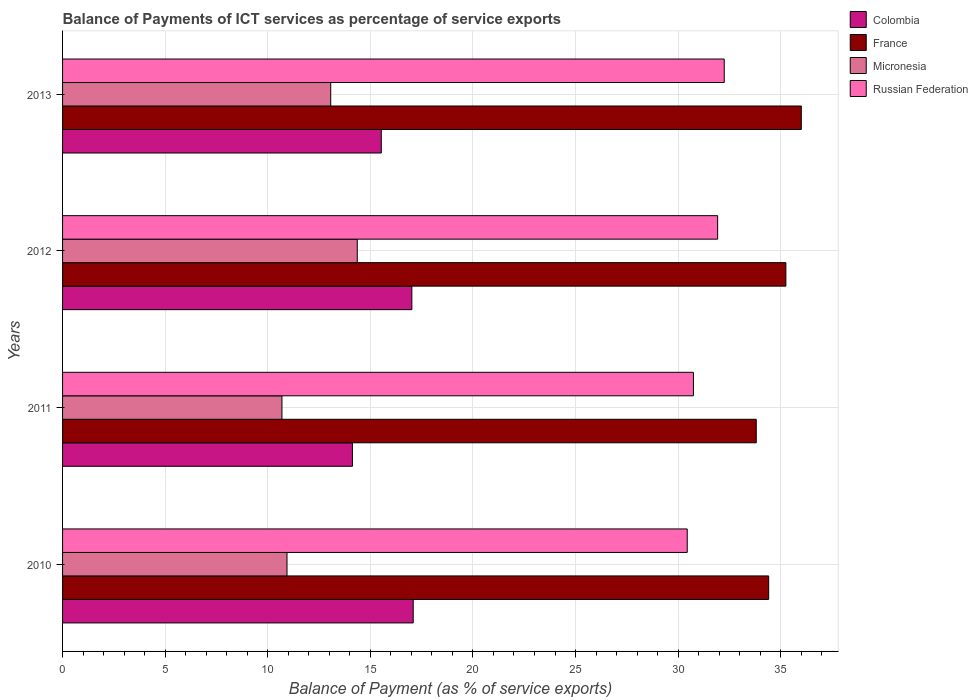How many different coloured bars are there?
Your answer should be very brief. 4. How many groups of bars are there?
Offer a very short reply. 4. Are the number of bars on each tick of the Y-axis equal?
Offer a very short reply. Yes. How many bars are there on the 3rd tick from the top?
Your answer should be compact. 4. What is the label of the 3rd group of bars from the top?
Keep it short and to the point. 2011. In how many cases, is the number of bars for a given year not equal to the number of legend labels?
Give a very brief answer. 0. What is the balance of payments of ICT services in Russian Federation in 2011?
Your answer should be very brief. 30.74. Across all years, what is the maximum balance of payments of ICT services in Colombia?
Ensure brevity in your answer.  17.09. Across all years, what is the minimum balance of payments of ICT services in Russian Federation?
Provide a succinct answer. 30.44. In which year was the balance of payments of ICT services in France minimum?
Your answer should be compact. 2011. What is the total balance of payments of ICT services in Russian Federation in the graph?
Offer a very short reply. 125.36. What is the difference between the balance of payments of ICT services in France in 2010 and that in 2011?
Make the answer very short. 0.61. What is the difference between the balance of payments of ICT services in France in 2011 and the balance of payments of ICT services in Colombia in 2012?
Your response must be concise. 16.78. What is the average balance of payments of ICT services in Colombia per year?
Make the answer very short. 15.94. In the year 2013, what is the difference between the balance of payments of ICT services in Micronesia and balance of payments of ICT services in France?
Your answer should be very brief. -22.93. In how many years, is the balance of payments of ICT services in Micronesia greater than 4 %?
Your response must be concise. 4. What is the ratio of the balance of payments of ICT services in Micronesia in 2010 to that in 2012?
Ensure brevity in your answer.  0.76. Is the difference between the balance of payments of ICT services in Micronesia in 2010 and 2013 greater than the difference between the balance of payments of ICT services in France in 2010 and 2013?
Give a very brief answer. No. What is the difference between the highest and the second highest balance of payments of ICT services in Russian Federation?
Keep it short and to the point. 0.32. What is the difference between the highest and the lowest balance of payments of ICT services in Colombia?
Provide a short and direct response. 2.96. In how many years, is the balance of payments of ICT services in Russian Federation greater than the average balance of payments of ICT services in Russian Federation taken over all years?
Keep it short and to the point. 2. Is the sum of the balance of payments of ICT services in Micronesia in 2010 and 2012 greater than the maximum balance of payments of ICT services in France across all years?
Provide a succinct answer. No. Is it the case that in every year, the sum of the balance of payments of ICT services in Colombia and balance of payments of ICT services in Micronesia is greater than the sum of balance of payments of ICT services in France and balance of payments of ICT services in Russian Federation?
Give a very brief answer. No. What does the 4th bar from the bottom in 2011 represents?
Give a very brief answer. Russian Federation. Are all the bars in the graph horizontal?
Your response must be concise. Yes. What is the difference between two consecutive major ticks on the X-axis?
Give a very brief answer. 5. Are the values on the major ticks of X-axis written in scientific E-notation?
Your answer should be very brief. No. Does the graph contain grids?
Your response must be concise. Yes. Where does the legend appear in the graph?
Offer a terse response. Top right. How many legend labels are there?
Offer a very short reply. 4. How are the legend labels stacked?
Offer a very short reply. Vertical. What is the title of the graph?
Offer a very short reply. Balance of Payments of ICT services as percentage of service exports. What is the label or title of the X-axis?
Keep it short and to the point. Balance of Payment (as % of service exports). What is the Balance of Payment (as % of service exports) in Colombia in 2010?
Offer a terse response. 17.09. What is the Balance of Payment (as % of service exports) of France in 2010?
Offer a terse response. 34.41. What is the Balance of Payment (as % of service exports) of Micronesia in 2010?
Ensure brevity in your answer.  10.94. What is the Balance of Payment (as % of service exports) of Russian Federation in 2010?
Keep it short and to the point. 30.44. What is the Balance of Payment (as % of service exports) in Colombia in 2011?
Provide a succinct answer. 14.13. What is the Balance of Payment (as % of service exports) of France in 2011?
Your answer should be compact. 33.81. What is the Balance of Payment (as % of service exports) of Micronesia in 2011?
Your answer should be very brief. 10.69. What is the Balance of Payment (as % of service exports) of Russian Federation in 2011?
Ensure brevity in your answer.  30.74. What is the Balance of Payment (as % of service exports) of Colombia in 2012?
Give a very brief answer. 17.02. What is the Balance of Payment (as % of service exports) of France in 2012?
Your response must be concise. 35.25. What is the Balance of Payment (as % of service exports) in Micronesia in 2012?
Your answer should be very brief. 14.36. What is the Balance of Payment (as % of service exports) in Russian Federation in 2012?
Provide a succinct answer. 31.92. What is the Balance of Payment (as % of service exports) of Colombia in 2013?
Offer a terse response. 15.53. What is the Balance of Payment (as % of service exports) in France in 2013?
Provide a succinct answer. 36. What is the Balance of Payment (as % of service exports) of Micronesia in 2013?
Provide a succinct answer. 13.07. What is the Balance of Payment (as % of service exports) of Russian Federation in 2013?
Keep it short and to the point. 32.25. Across all years, what is the maximum Balance of Payment (as % of service exports) in Colombia?
Keep it short and to the point. 17.09. Across all years, what is the maximum Balance of Payment (as % of service exports) in France?
Offer a terse response. 36. Across all years, what is the maximum Balance of Payment (as % of service exports) of Micronesia?
Make the answer very short. 14.36. Across all years, what is the maximum Balance of Payment (as % of service exports) of Russian Federation?
Offer a terse response. 32.25. Across all years, what is the minimum Balance of Payment (as % of service exports) of Colombia?
Keep it short and to the point. 14.13. Across all years, what is the minimum Balance of Payment (as % of service exports) in France?
Your answer should be compact. 33.81. Across all years, what is the minimum Balance of Payment (as % of service exports) in Micronesia?
Make the answer very short. 10.69. Across all years, what is the minimum Balance of Payment (as % of service exports) of Russian Federation?
Provide a succinct answer. 30.44. What is the total Balance of Payment (as % of service exports) in Colombia in the graph?
Offer a terse response. 63.77. What is the total Balance of Payment (as % of service exports) in France in the graph?
Ensure brevity in your answer.  139.47. What is the total Balance of Payment (as % of service exports) of Micronesia in the graph?
Offer a terse response. 49.06. What is the total Balance of Payment (as % of service exports) of Russian Federation in the graph?
Ensure brevity in your answer.  125.36. What is the difference between the Balance of Payment (as % of service exports) of Colombia in 2010 and that in 2011?
Your answer should be very brief. 2.96. What is the difference between the Balance of Payment (as % of service exports) in France in 2010 and that in 2011?
Offer a very short reply. 0.61. What is the difference between the Balance of Payment (as % of service exports) of Micronesia in 2010 and that in 2011?
Give a very brief answer. 0.25. What is the difference between the Balance of Payment (as % of service exports) of Russian Federation in 2010 and that in 2011?
Provide a succinct answer. -0.3. What is the difference between the Balance of Payment (as % of service exports) of Colombia in 2010 and that in 2012?
Give a very brief answer. 0.07. What is the difference between the Balance of Payment (as % of service exports) of France in 2010 and that in 2012?
Ensure brevity in your answer.  -0.84. What is the difference between the Balance of Payment (as % of service exports) in Micronesia in 2010 and that in 2012?
Keep it short and to the point. -3.42. What is the difference between the Balance of Payment (as % of service exports) in Russian Federation in 2010 and that in 2012?
Your answer should be compact. -1.48. What is the difference between the Balance of Payment (as % of service exports) of Colombia in 2010 and that in 2013?
Your answer should be compact. 1.56. What is the difference between the Balance of Payment (as % of service exports) of France in 2010 and that in 2013?
Your answer should be very brief. -1.59. What is the difference between the Balance of Payment (as % of service exports) in Micronesia in 2010 and that in 2013?
Your response must be concise. -2.13. What is the difference between the Balance of Payment (as % of service exports) of Russian Federation in 2010 and that in 2013?
Offer a terse response. -1.8. What is the difference between the Balance of Payment (as % of service exports) of Colombia in 2011 and that in 2012?
Offer a very short reply. -2.9. What is the difference between the Balance of Payment (as % of service exports) in France in 2011 and that in 2012?
Offer a terse response. -1.44. What is the difference between the Balance of Payment (as % of service exports) in Micronesia in 2011 and that in 2012?
Give a very brief answer. -3.67. What is the difference between the Balance of Payment (as % of service exports) of Russian Federation in 2011 and that in 2012?
Make the answer very short. -1.18. What is the difference between the Balance of Payment (as % of service exports) in Colombia in 2011 and that in 2013?
Provide a short and direct response. -1.41. What is the difference between the Balance of Payment (as % of service exports) in France in 2011 and that in 2013?
Your response must be concise. -2.19. What is the difference between the Balance of Payment (as % of service exports) in Micronesia in 2011 and that in 2013?
Give a very brief answer. -2.38. What is the difference between the Balance of Payment (as % of service exports) in Russian Federation in 2011 and that in 2013?
Give a very brief answer. -1.5. What is the difference between the Balance of Payment (as % of service exports) in Colombia in 2012 and that in 2013?
Your answer should be very brief. 1.49. What is the difference between the Balance of Payment (as % of service exports) of France in 2012 and that in 2013?
Ensure brevity in your answer.  -0.75. What is the difference between the Balance of Payment (as % of service exports) of Micronesia in 2012 and that in 2013?
Provide a short and direct response. 1.29. What is the difference between the Balance of Payment (as % of service exports) in Russian Federation in 2012 and that in 2013?
Provide a succinct answer. -0.32. What is the difference between the Balance of Payment (as % of service exports) of Colombia in 2010 and the Balance of Payment (as % of service exports) of France in 2011?
Your answer should be compact. -16.72. What is the difference between the Balance of Payment (as % of service exports) in Colombia in 2010 and the Balance of Payment (as % of service exports) in Micronesia in 2011?
Ensure brevity in your answer.  6.4. What is the difference between the Balance of Payment (as % of service exports) of Colombia in 2010 and the Balance of Payment (as % of service exports) of Russian Federation in 2011?
Give a very brief answer. -13.66. What is the difference between the Balance of Payment (as % of service exports) in France in 2010 and the Balance of Payment (as % of service exports) in Micronesia in 2011?
Keep it short and to the point. 23.72. What is the difference between the Balance of Payment (as % of service exports) in France in 2010 and the Balance of Payment (as % of service exports) in Russian Federation in 2011?
Provide a succinct answer. 3.67. What is the difference between the Balance of Payment (as % of service exports) of Micronesia in 2010 and the Balance of Payment (as % of service exports) of Russian Federation in 2011?
Your answer should be very brief. -19.81. What is the difference between the Balance of Payment (as % of service exports) in Colombia in 2010 and the Balance of Payment (as % of service exports) in France in 2012?
Provide a short and direct response. -18.16. What is the difference between the Balance of Payment (as % of service exports) of Colombia in 2010 and the Balance of Payment (as % of service exports) of Micronesia in 2012?
Make the answer very short. 2.73. What is the difference between the Balance of Payment (as % of service exports) of Colombia in 2010 and the Balance of Payment (as % of service exports) of Russian Federation in 2012?
Keep it short and to the point. -14.84. What is the difference between the Balance of Payment (as % of service exports) of France in 2010 and the Balance of Payment (as % of service exports) of Micronesia in 2012?
Make the answer very short. 20.05. What is the difference between the Balance of Payment (as % of service exports) of France in 2010 and the Balance of Payment (as % of service exports) of Russian Federation in 2012?
Provide a succinct answer. 2.49. What is the difference between the Balance of Payment (as % of service exports) of Micronesia in 2010 and the Balance of Payment (as % of service exports) of Russian Federation in 2012?
Ensure brevity in your answer.  -20.99. What is the difference between the Balance of Payment (as % of service exports) of Colombia in 2010 and the Balance of Payment (as % of service exports) of France in 2013?
Keep it short and to the point. -18.91. What is the difference between the Balance of Payment (as % of service exports) in Colombia in 2010 and the Balance of Payment (as % of service exports) in Micronesia in 2013?
Provide a succinct answer. 4.02. What is the difference between the Balance of Payment (as % of service exports) in Colombia in 2010 and the Balance of Payment (as % of service exports) in Russian Federation in 2013?
Offer a very short reply. -15.16. What is the difference between the Balance of Payment (as % of service exports) of France in 2010 and the Balance of Payment (as % of service exports) of Micronesia in 2013?
Provide a succinct answer. 21.34. What is the difference between the Balance of Payment (as % of service exports) of France in 2010 and the Balance of Payment (as % of service exports) of Russian Federation in 2013?
Provide a short and direct response. 2.17. What is the difference between the Balance of Payment (as % of service exports) of Micronesia in 2010 and the Balance of Payment (as % of service exports) of Russian Federation in 2013?
Your answer should be very brief. -21.31. What is the difference between the Balance of Payment (as % of service exports) of Colombia in 2011 and the Balance of Payment (as % of service exports) of France in 2012?
Offer a terse response. -21.12. What is the difference between the Balance of Payment (as % of service exports) of Colombia in 2011 and the Balance of Payment (as % of service exports) of Micronesia in 2012?
Your response must be concise. -0.24. What is the difference between the Balance of Payment (as % of service exports) of Colombia in 2011 and the Balance of Payment (as % of service exports) of Russian Federation in 2012?
Make the answer very short. -17.8. What is the difference between the Balance of Payment (as % of service exports) in France in 2011 and the Balance of Payment (as % of service exports) in Micronesia in 2012?
Ensure brevity in your answer.  19.44. What is the difference between the Balance of Payment (as % of service exports) in France in 2011 and the Balance of Payment (as % of service exports) in Russian Federation in 2012?
Ensure brevity in your answer.  1.88. What is the difference between the Balance of Payment (as % of service exports) of Micronesia in 2011 and the Balance of Payment (as % of service exports) of Russian Federation in 2012?
Keep it short and to the point. -21.23. What is the difference between the Balance of Payment (as % of service exports) of Colombia in 2011 and the Balance of Payment (as % of service exports) of France in 2013?
Give a very brief answer. -21.88. What is the difference between the Balance of Payment (as % of service exports) in Colombia in 2011 and the Balance of Payment (as % of service exports) in Micronesia in 2013?
Give a very brief answer. 1.06. What is the difference between the Balance of Payment (as % of service exports) of Colombia in 2011 and the Balance of Payment (as % of service exports) of Russian Federation in 2013?
Keep it short and to the point. -18.12. What is the difference between the Balance of Payment (as % of service exports) of France in 2011 and the Balance of Payment (as % of service exports) of Micronesia in 2013?
Keep it short and to the point. 20.74. What is the difference between the Balance of Payment (as % of service exports) of France in 2011 and the Balance of Payment (as % of service exports) of Russian Federation in 2013?
Offer a very short reply. 1.56. What is the difference between the Balance of Payment (as % of service exports) of Micronesia in 2011 and the Balance of Payment (as % of service exports) of Russian Federation in 2013?
Provide a succinct answer. -21.55. What is the difference between the Balance of Payment (as % of service exports) of Colombia in 2012 and the Balance of Payment (as % of service exports) of France in 2013?
Keep it short and to the point. -18.98. What is the difference between the Balance of Payment (as % of service exports) of Colombia in 2012 and the Balance of Payment (as % of service exports) of Micronesia in 2013?
Ensure brevity in your answer.  3.95. What is the difference between the Balance of Payment (as % of service exports) of Colombia in 2012 and the Balance of Payment (as % of service exports) of Russian Federation in 2013?
Provide a short and direct response. -15.22. What is the difference between the Balance of Payment (as % of service exports) of France in 2012 and the Balance of Payment (as % of service exports) of Micronesia in 2013?
Ensure brevity in your answer.  22.18. What is the difference between the Balance of Payment (as % of service exports) of France in 2012 and the Balance of Payment (as % of service exports) of Russian Federation in 2013?
Offer a terse response. 3. What is the difference between the Balance of Payment (as % of service exports) in Micronesia in 2012 and the Balance of Payment (as % of service exports) in Russian Federation in 2013?
Offer a very short reply. -17.88. What is the average Balance of Payment (as % of service exports) in Colombia per year?
Provide a short and direct response. 15.94. What is the average Balance of Payment (as % of service exports) of France per year?
Your response must be concise. 34.87. What is the average Balance of Payment (as % of service exports) in Micronesia per year?
Your answer should be compact. 12.27. What is the average Balance of Payment (as % of service exports) of Russian Federation per year?
Your response must be concise. 31.34. In the year 2010, what is the difference between the Balance of Payment (as % of service exports) of Colombia and Balance of Payment (as % of service exports) of France?
Your response must be concise. -17.32. In the year 2010, what is the difference between the Balance of Payment (as % of service exports) in Colombia and Balance of Payment (as % of service exports) in Micronesia?
Make the answer very short. 6.15. In the year 2010, what is the difference between the Balance of Payment (as % of service exports) in Colombia and Balance of Payment (as % of service exports) in Russian Federation?
Make the answer very short. -13.35. In the year 2010, what is the difference between the Balance of Payment (as % of service exports) of France and Balance of Payment (as % of service exports) of Micronesia?
Provide a succinct answer. 23.47. In the year 2010, what is the difference between the Balance of Payment (as % of service exports) of France and Balance of Payment (as % of service exports) of Russian Federation?
Ensure brevity in your answer.  3.97. In the year 2010, what is the difference between the Balance of Payment (as % of service exports) of Micronesia and Balance of Payment (as % of service exports) of Russian Federation?
Your response must be concise. -19.5. In the year 2011, what is the difference between the Balance of Payment (as % of service exports) of Colombia and Balance of Payment (as % of service exports) of France?
Your answer should be very brief. -19.68. In the year 2011, what is the difference between the Balance of Payment (as % of service exports) of Colombia and Balance of Payment (as % of service exports) of Micronesia?
Offer a very short reply. 3.43. In the year 2011, what is the difference between the Balance of Payment (as % of service exports) in Colombia and Balance of Payment (as % of service exports) in Russian Federation?
Provide a short and direct response. -16.62. In the year 2011, what is the difference between the Balance of Payment (as % of service exports) of France and Balance of Payment (as % of service exports) of Micronesia?
Your answer should be very brief. 23.11. In the year 2011, what is the difference between the Balance of Payment (as % of service exports) in France and Balance of Payment (as % of service exports) in Russian Federation?
Provide a succinct answer. 3.06. In the year 2011, what is the difference between the Balance of Payment (as % of service exports) in Micronesia and Balance of Payment (as % of service exports) in Russian Federation?
Ensure brevity in your answer.  -20.05. In the year 2012, what is the difference between the Balance of Payment (as % of service exports) in Colombia and Balance of Payment (as % of service exports) in France?
Your response must be concise. -18.23. In the year 2012, what is the difference between the Balance of Payment (as % of service exports) in Colombia and Balance of Payment (as % of service exports) in Micronesia?
Offer a very short reply. 2.66. In the year 2012, what is the difference between the Balance of Payment (as % of service exports) in Colombia and Balance of Payment (as % of service exports) in Russian Federation?
Provide a short and direct response. -14.9. In the year 2012, what is the difference between the Balance of Payment (as % of service exports) in France and Balance of Payment (as % of service exports) in Micronesia?
Offer a very short reply. 20.89. In the year 2012, what is the difference between the Balance of Payment (as % of service exports) of France and Balance of Payment (as % of service exports) of Russian Federation?
Your answer should be very brief. 3.33. In the year 2012, what is the difference between the Balance of Payment (as % of service exports) in Micronesia and Balance of Payment (as % of service exports) in Russian Federation?
Your response must be concise. -17.56. In the year 2013, what is the difference between the Balance of Payment (as % of service exports) in Colombia and Balance of Payment (as % of service exports) in France?
Your answer should be compact. -20.47. In the year 2013, what is the difference between the Balance of Payment (as % of service exports) of Colombia and Balance of Payment (as % of service exports) of Micronesia?
Your answer should be very brief. 2.46. In the year 2013, what is the difference between the Balance of Payment (as % of service exports) in Colombia and Balance of Payment (as % of service exports) in Russian Federation?
Offer a terse response. -16.71. In the year 2013, what is the difference between the Balance of Payment (as % of service exports) of France and Balance of Payment (as % of service exports) of Micronesia?
Your response must be concise. 22.93. In the year 2013, what is the difference between the Balance of Payment (as % of service exports) of France and Balance of Payment (as % of service exports) of Russian Federation?
Make the answer very short. 3.76. In the year 2013, what is the difference between the Balance of Payment (as % of service exports) in Micronesia and Balance of Payment (as % of service exports) in Russian Federation?
Your answer should be compact. -19.18. What is the ratio of the Balance of Payment (as % of service exports) in Colombia in 2010 to that in 2011?
Your answer should be very brief. 1.21. What is the ratio of the Balance of Payment (as % of service exports) of France in 2010 to that in 2011?
Provide a succinct answer. 1.02. What is the ratio of the Balance of Payment (as % of service exports) in Russian Federation in 2010 to that in 2011?
Your response must be concise. 0.99. What is the ratio of the Balance of Payment (as % of service exports) in Colombia in 2010 to that in 2012?
Keep it short and to the point. 1. What is the ratio of the Balance of Payment (as % of service exports) in France in 2010 to that in 2012?
Offer a very short reply. 0.98. What is the ratio of the Balance of Payment (as % of service exports) in Micronesia in 2010 to that in 2012?
Provide a succinct answer. 0.76. What is the ratio of the Balance of Payment (as % of service exports) of Russian Federation in 2010 to that in 2012?
Your response must be concise. 0.95. What is the ratio of the Balance of Payment (as % of service exports) of Colombia in 2010 to that in 2013?
Offer a terse response. 1.1. What is the ratio of the Balance of Payment (as % of service exports) in France in 2010 to that in 2013?
Offer a terse response. 0.96. What is the ratio of the Balance of Payment (as % of service exports) in Micronesia in 2010 to that in 2013?
Offer a very short reply. 0.84. What is the ratio of the Balance of Payment (as % of service exports) of Russian Federation in 2010 to that in 2013?
Your answer should be compact. 0.94. What is the ratio of the Balance of Payment (as % of service exports) of Colombia in 2011 to that in 2012?
Provide a short and direct response. 0.83. What is the ratio of the Balance of Payment (as % of service exports) in France in 2011 to that in 2012?
Offer a terse response. 0.96. What is the ratio of the Balance of Payment (as % of service exports) in Micronesia in 2011 to that in 2012?
Offer a very short reply. 0.74. What is the ratio of the Balance of Payment (as % of service exports) of Russian Federation in 2011 to that in 2012?
Keep it short and to the point. 0.96. What is the ratio of the Balance of Payment (as % of service exports) in Colombia in 2011 to that in 2013?
Ensure brevity in your answer.  0.91. What is the ratio of the Balance of Payment (as % of service exports) in France in 2011 to that in 2013?
Provide a short and direct response. 0.94. What is the ratio of the Balance of Payment (as % of service exports) of Micronesia in 2011 to that in 2013?
Provide a succinct answer. 0.82. What is the ratio of the Balance of Payment (as % of service exports) in Russian Federation in 2011 to that in 2013?
Ensure brevity in your answer.  0.95. What is the ratio of the Balance of Payment (as % of service exports) in Colombia in 2012 to that in 2013?
Ensure brevity in your answer.  1.1. What is the ratio of the Balance of Payment (as % of service exports) in France in 2012 to that in 2013?
Provide a succinct answer. 0.98. What is the ratio of the Balance of Payment (as % of service exports) in Micronesia in 2012 to that in 2013?
Offer a terse response. 1.1. What is the ratio of the Balance of Payment (as % of service exports) of Russian Federation in 2012 to that in 2013?
Provide a short and direct response. 0.99. What is the difference between the highest and the second highest Balance of Payment (as % of service exports) in Colombia?
Make the answer very short. 0.07. What is the difference between the highest and the second highest Balance of Payment (as % of service exports) in France?
Your response must be concise. 0.75. What is the difference between the highest and the second highest Balance of Payment (as % of service exports) in Micronesia?
Your response must be concise. 1.29. What is the difference between the highest and the second highest Balance of Payment (as % of service exports) of Russian Federation?
Give a very brief answer. 0.32. What is the difference between the highest and the lowest Balance of Payment (as % of service exports) of Colombia?
Provide a succinct answer. 2.96. What is the difference between the highest and the lowest Balance of Payment (as % of service exports) of France?
Your answer should be very brief. 2.19. What is the difference between the highest and the lowest Balance of Payment (as % of service exports) of Micronesia?
Your answer should be very brief. 3.67. What is the difference between the highest and the lowest Balance of Payment (as % of service exports) in Russian Federation?
Give a very brief answer. 1.8. 